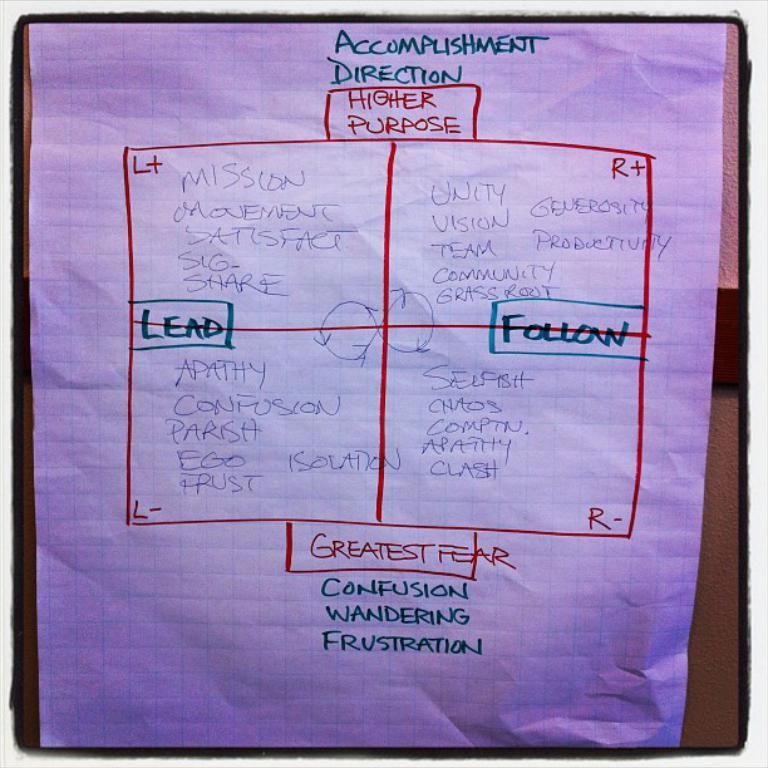<image>
Write a terse but informative summary of the picture. Paper with the word "Accomplishment Direction" on the top. 